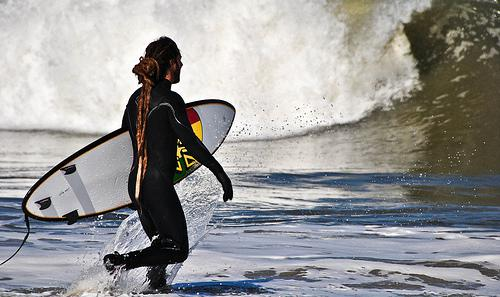Question: when is the picture taken?
Choices:
A. At night.
B. In the morning.
C. In the afternoon.
D. During the day.
Answer with the letter. Answer: D Question: why is the man holding a surfboard?
Choices:
A. He works in a surfboard shop.
B. He makes surfboards for a living.
C. He is going to surf.
D. He is a surfer who is moving and is carrying his surfboard to his new house.
Answer with the letter. Answer: C Question: how many men are in the photo?
Choices:
A. None.
B. One.
C. Three.
D. Four.
Answer with the letter. Answer: B Question: where is the man?
Choices:
A. In New York.
B. In Utah.
C. In the desert.
D. On the beach.
Answer with the letter. Answer: D 